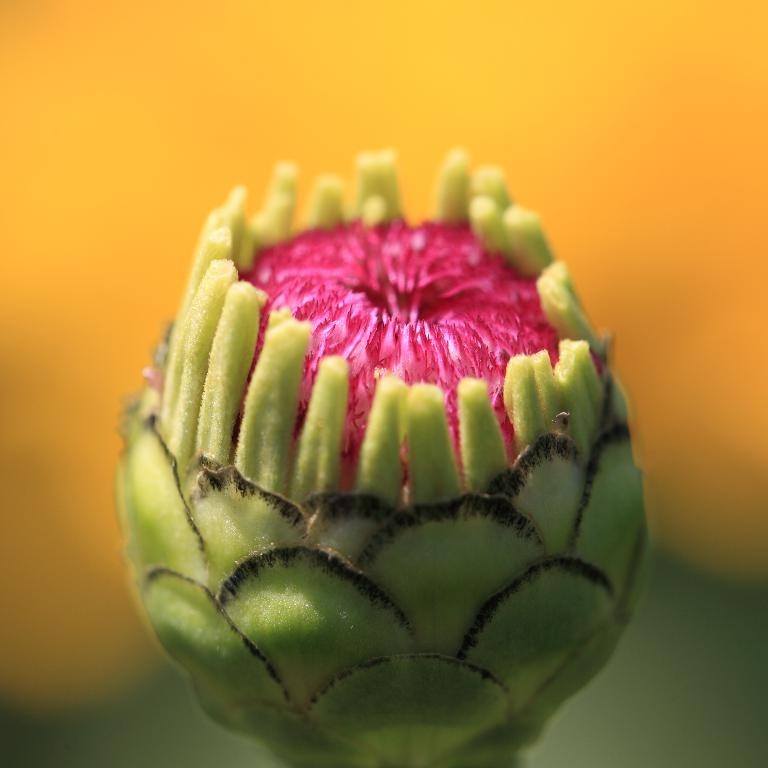What is the main subject of the picture? The main subject of the picture is a flower bud. Can you describe the color of the flower bud? The flower bud is light green in color. Is there any other color visible on the flower bud? Yes, there is a pink area in the middle of the flower bud. What color is the background of the image? The background of the image is yellow. What type of mountain can be seen in the background of the image? There is no mountain visible in the image; the background is yellow. What is the condition of the playground in the image? There is no playground present in the image. 